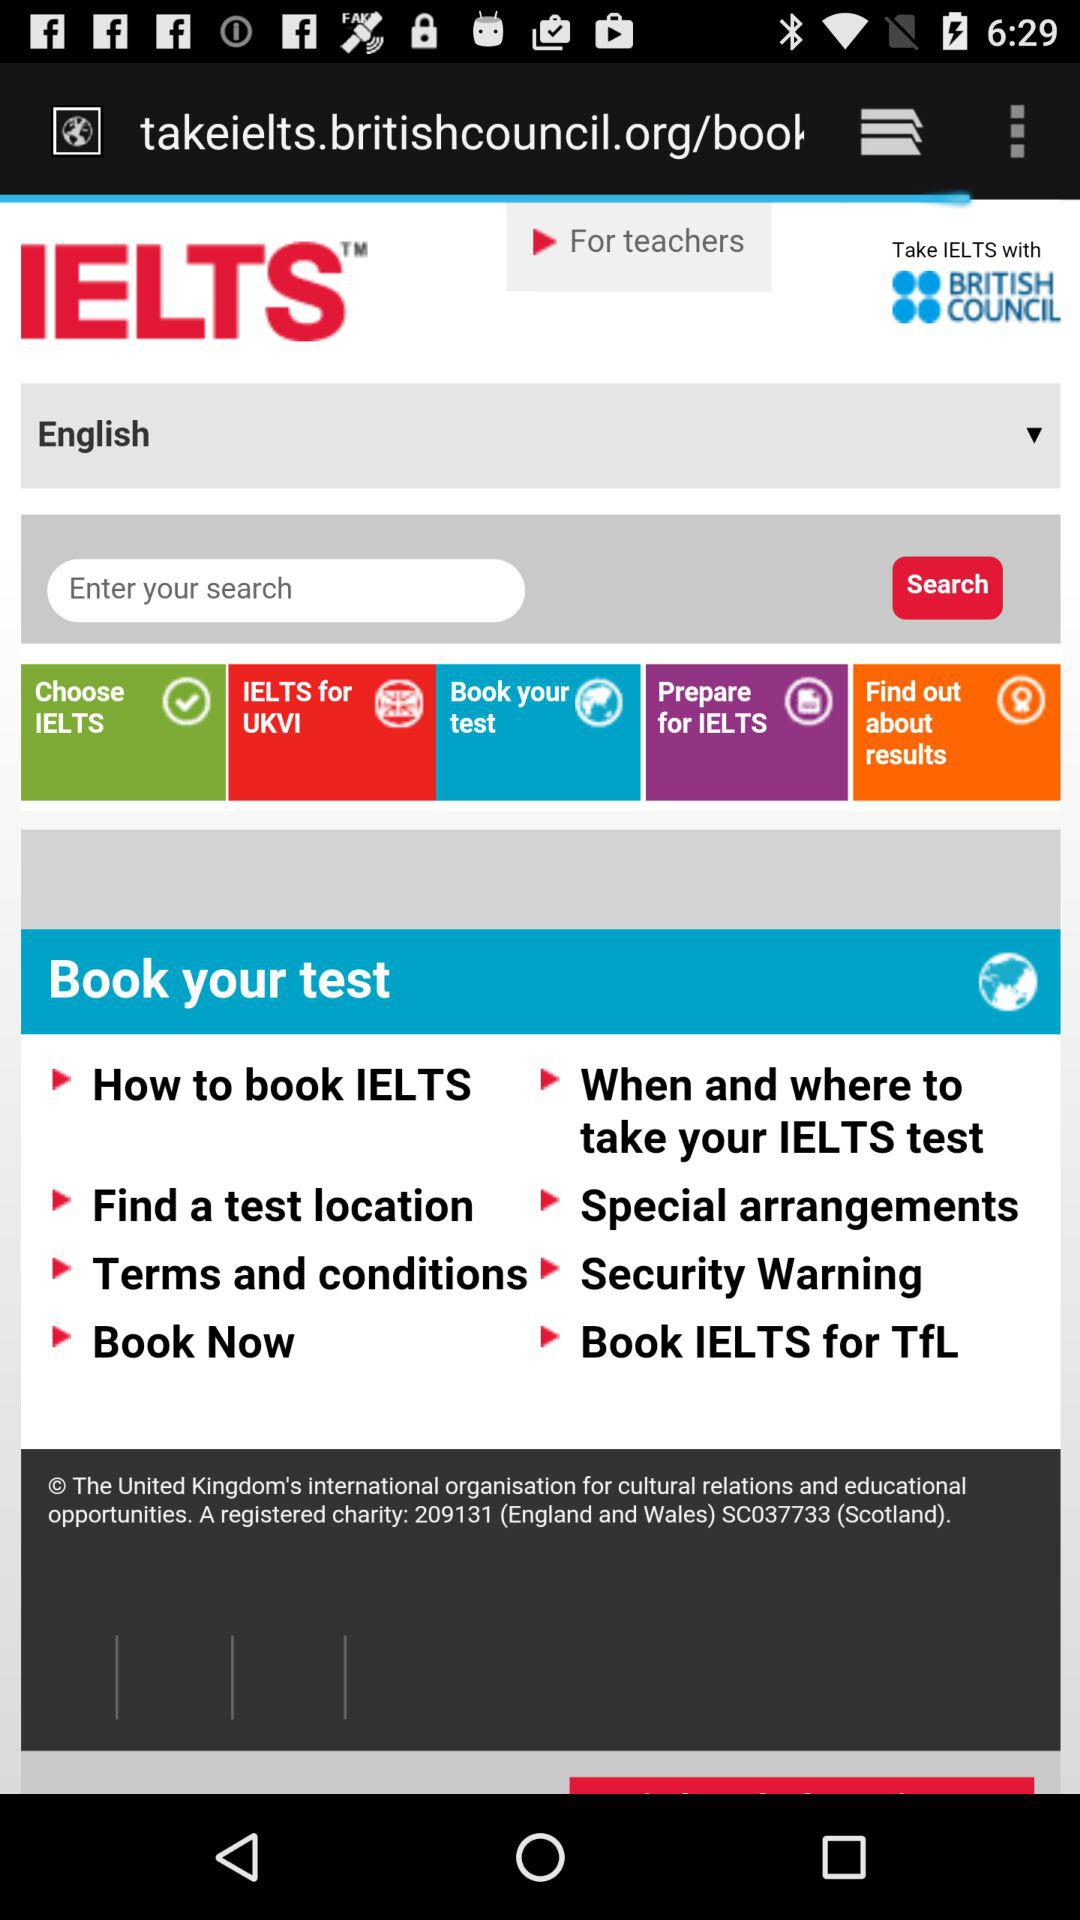What is the name of the course? The name of the course is IELTS. 